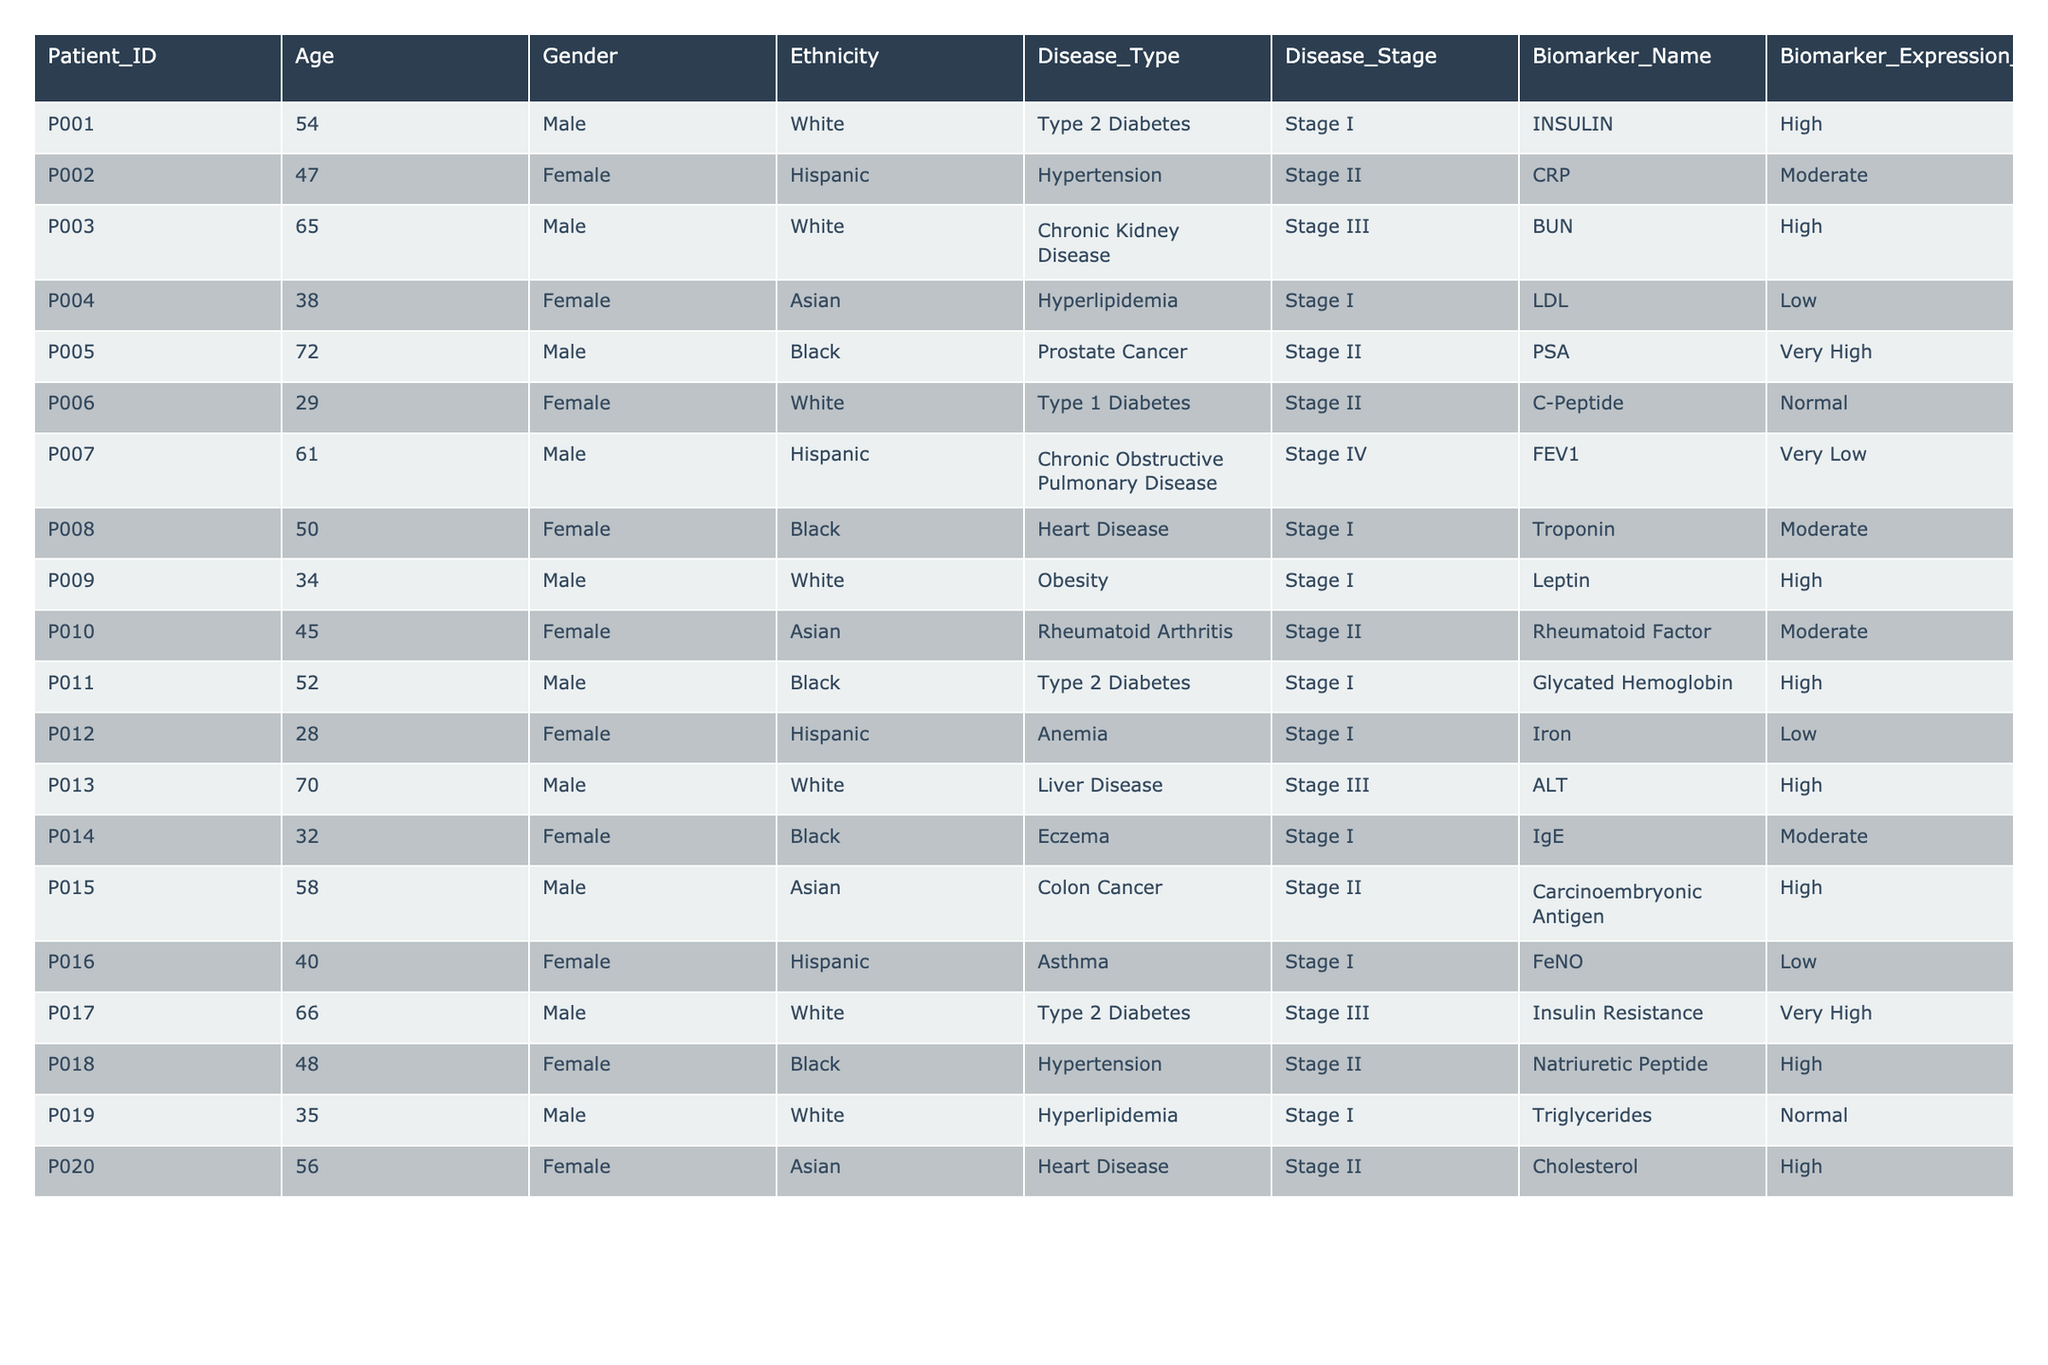What is the Biomarker Expression Level for Patient ID P005? Looking at the table, Patient ID P005 has the Biomarker Expression Level recorded as "Very High."
Answer: Very High How many Females are recorded in the table? By counting the entries in the Gender column, there are 10 Females listed in the table.
Answer: 10 Do any patients have a Disease Stage of Stage IV? The table shows that Patient ID P007 is the only patient with a Disease Stage of Stage IV.
Answer: True What is the average age of male patients in the table? The ages of male patients are 54, 65, 72, 61, 58, 66, contributing to a total of 406. Since there are 7 males, the average age is 406/7 = 58.14.
Answer: 58.14 Which Disease Type is associated with the highest number of patients? By examining the Disease_Type column, we see that "Type 2 Diabetes" and "Hypertension" each have 3 patients, which is the highest for any disease type.
Answer: Type 2 Diabetes and Hypertension What is the proportion of patients with a Low Biomarker Expression Level? There are 4 patients with a Low Expression Level out of 20 total patients, giving a proportion of 4/20 = 0.20 or 20%.
Answer: 20% Is there any patient with a Disease Type of "Chronic Kidney Disease" that has a Biomarker Expression Level of High? Yes, Patient ID P003 has a Disease Type of "Chronic Kidney Disease" and a Biomarker Expression Level of High.
Answer: True What is the highest Biomarker Expression Level recorded and for which Patient? The highest Biomarker Expression Level recorded is "Very High," which corresponds to Patient ID P005.
Answer: Very High, P005 How many different ethnicities are represented among patients with "Stage II" disease? Counting the unique ethnicities in the Stage II category: Hispanic (P002, P006), Black (P005, P018), White (P010), and Asian (P020), gives us 4 distinct ethnicities.
Answer: 4 Which disease type has the lowest average age of patients? Examining the ages and disease types, "Anemia" (Age 28) has the lowest average age. No other disease type has younger patients on average.
Answer: Anemia 